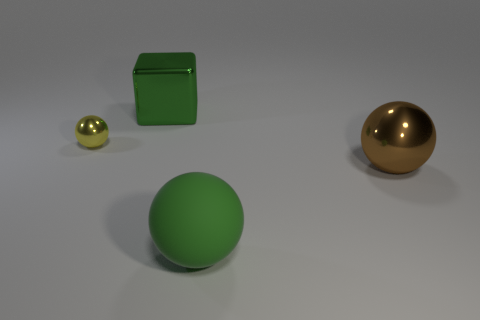Could these objects represent any scientific concept if used in an educational context? Yes, these objects could serve to demonstrate various scientific principles. For example, they could represent atoms of different elements in a molecule, with their sizes indicative of relative atomic size or mass. Alternatively, the spheres can be used to talk about geometric shapes and their properties, and the cube can help illustrate solid geometry concepts. 